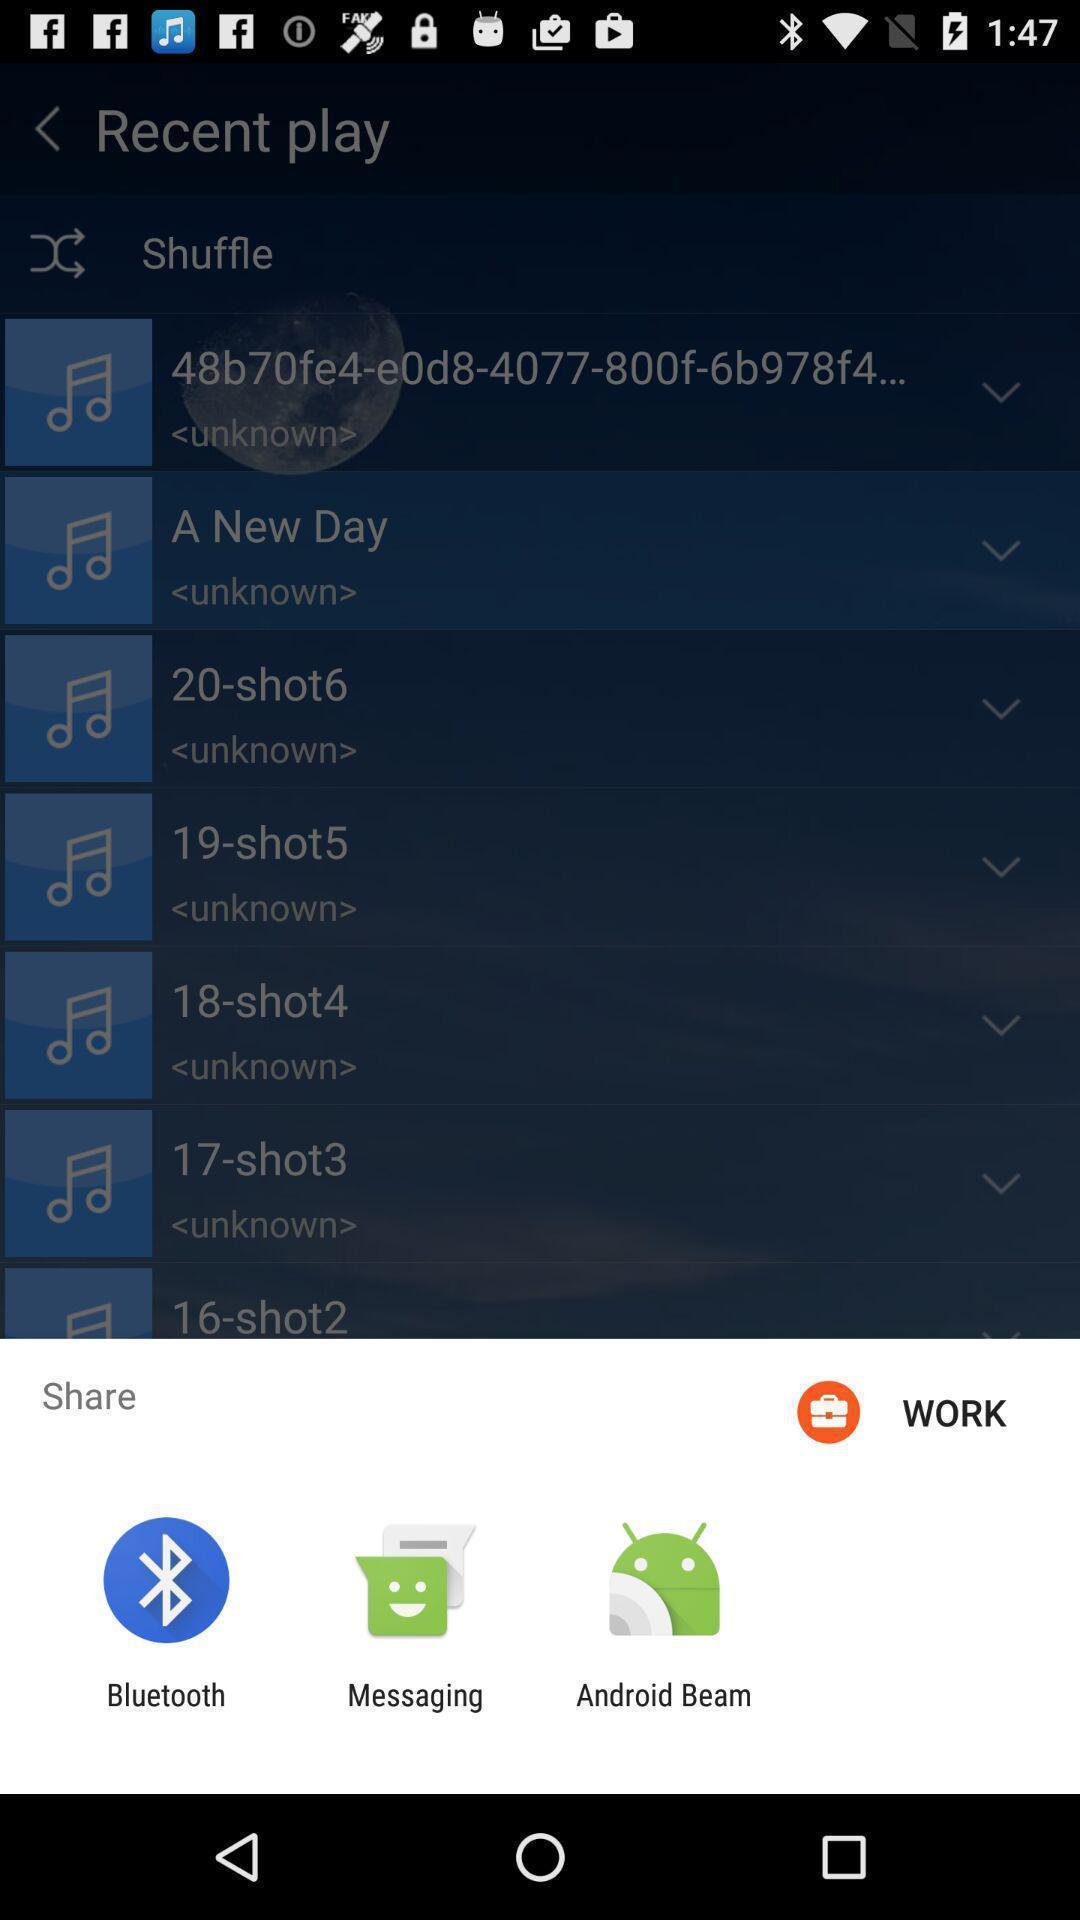Summarize the main components in this picture. Pop-up showing various sharing options. 